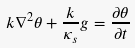<formula> <loc_0><loc_0><loc_500><loc_500>k \nabla ^ { 2 } \theta + \frac { k } { \kappa _ { s } } g = \frac { \partial \theta } { \partial t }</formula> 